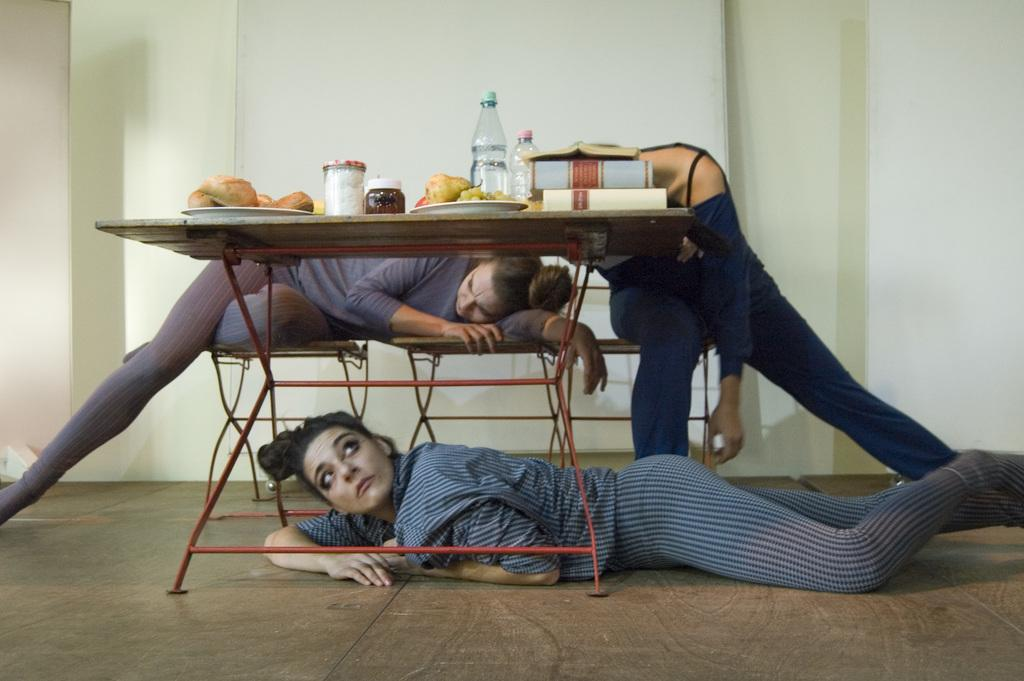What type of furniture is present in the image? There are tables and chairs in the image. What are people doing with the chairs in the image? People are sitting on the chairs in the image. Can you describe the position of one person in the image? One person is lying down. What items can be seen on the table in the image? There are books, water bottles, plates, eatables, and jars on the table in the image. How fast is the bat running across the table in the image? There is no bat present in the image, so it cannot be running across the table. 